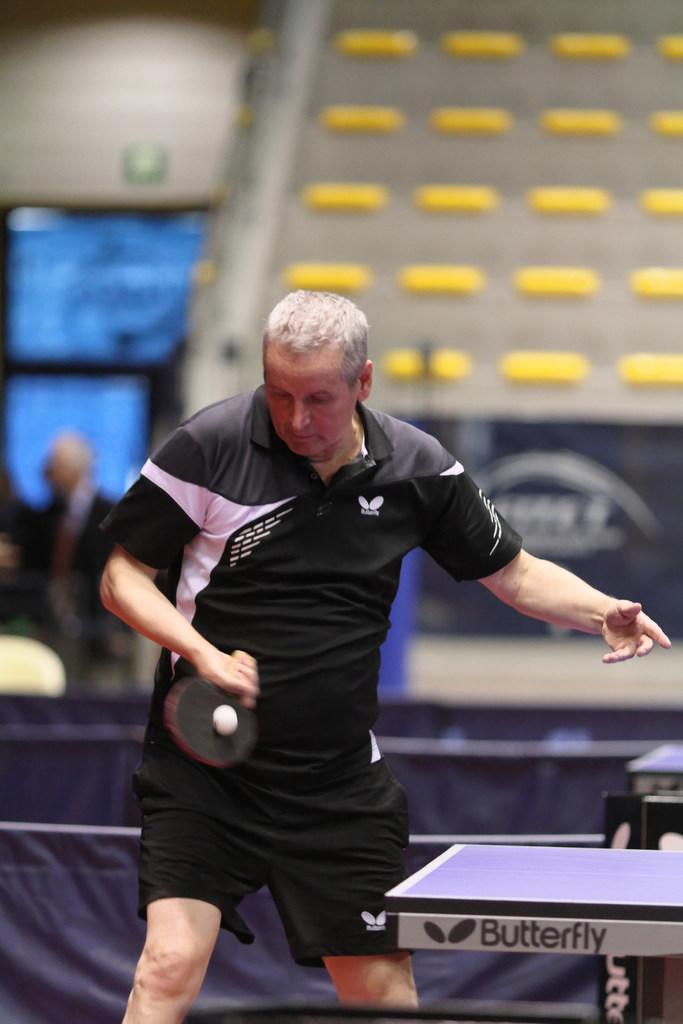In one or two sentences, can you explain what this image depicts? In the foreground a person is standing and playing table tennis in front of the table which is visible half. In the background a person is standing and fence is visible and seats are visible. This image is taken inside a indoor hall. 